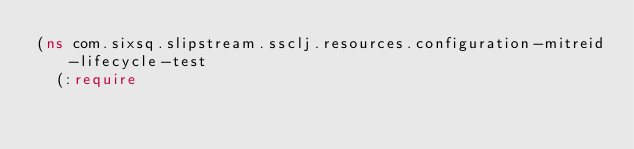Convert code to text. <code><loc_0><loc_0><loc_500><loc_500><_Clojure_>(ns com.sixsq.slipstream.ssclj.resources.configuration-mitreid-lifecycle-test
  (:require</code> 